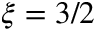Convert formula to latex. <formula><loc_0><loc_0><loc_500><loc_500>\xi = 3 / 2</formula> 